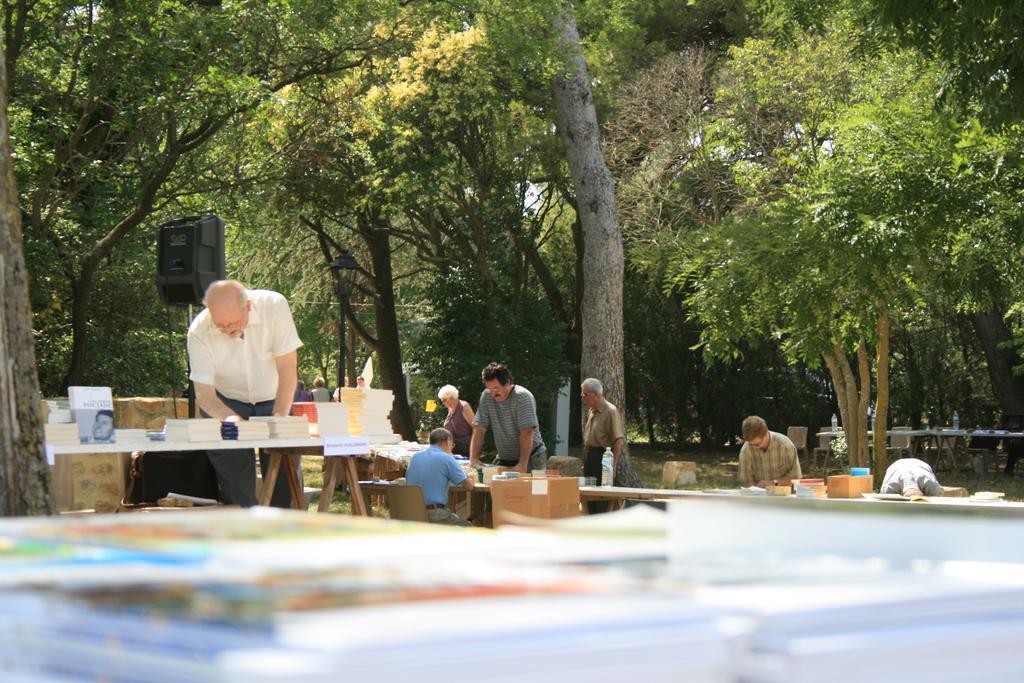Can you describe this image briefly? In this image I see few people in which this man is sitting on a chair and I see books and I can also see a black color thing over here. In the background I see the trees and I see tables over here and I see the chairs and I see a bottle over here and I see few things on this table. 